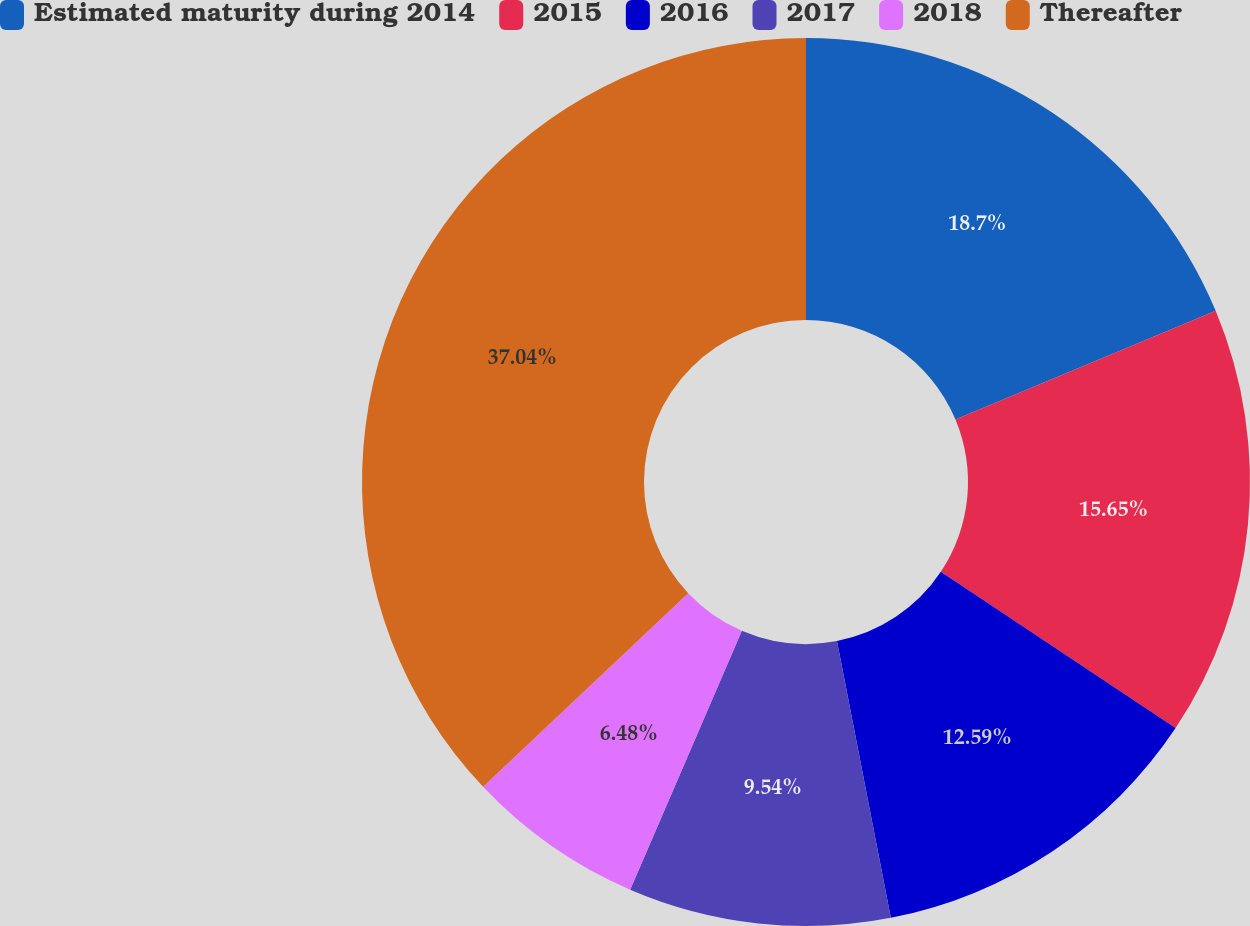<chart> <loc_0><loc_0><loc_500><loc_500><pie_chart><fcel>Estimated maturity during 2014<fcel>2015<fcel>2016<fcel>2017<fcel>2018<fcel>Thereafter<nl><fcel>18.7%<fcel>15.65%<fcel>12.59%<fcel>9.54%<fcel>6.48%<fcel>37.04%<nl></chart> 